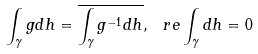<formula> <loc_0><loc_0><loc_500><loc_500>\int _ { \gamma } g d h = \overline { \int _ { \gamma } g ^ { - 1 } d h } , \, \ r e \int _ { \gamma } d h = 0</formula> 